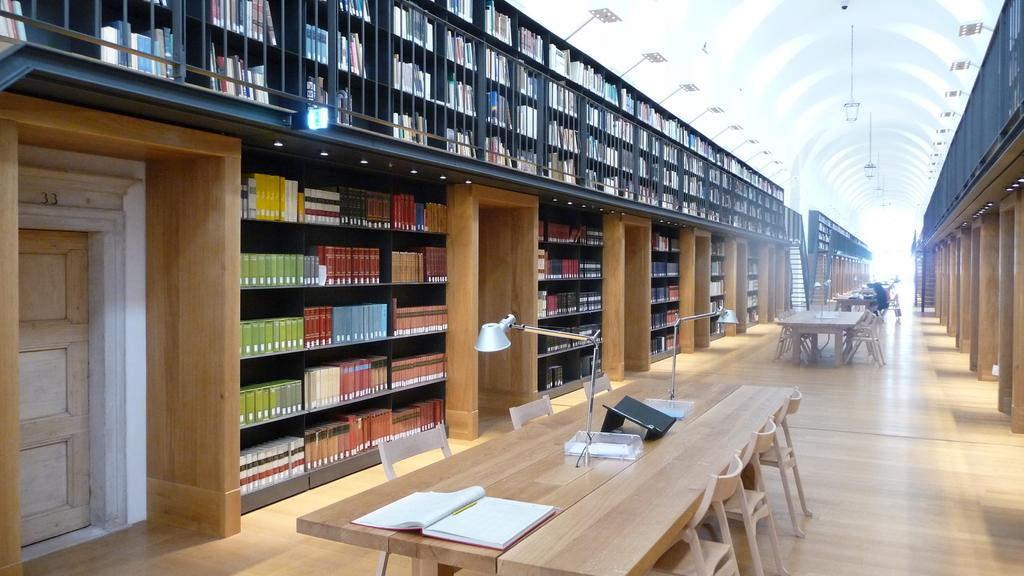What piece of furniture is present in the image? There is a table in the image. What is placed on the table? There is a book and a pen on the table. Can you describe the arrangement of books in the image? There are books arranged on a shelf. What activity are the people in the image engaged in? There are people sitting and reading in the image. Can you see any deer wearing a mask in the image? No, there are no deer or masks present in the image. Are there any fangs visible on the people reading in the image? No, there are no fangs visible on the people in the image. 